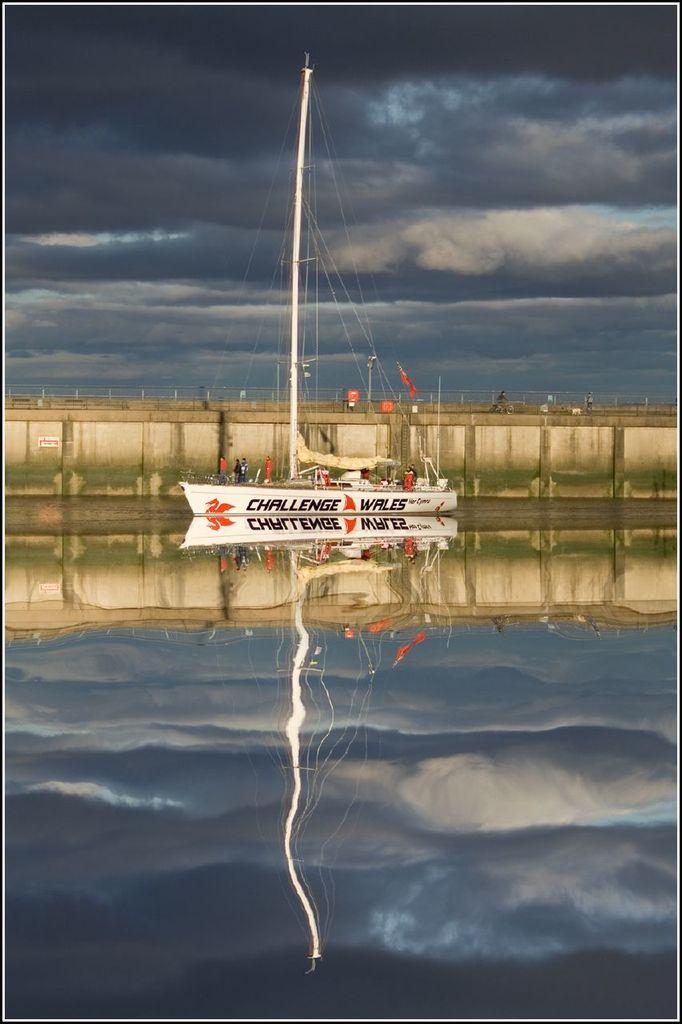What is in the water in the image? There is a boat in the water in the image. What can be seen in the background of the image? There is a wall in the background of the image. What is the weather like in the image? The presence of black clouds at the top of the image suggests that it might be overcast or stormy. What is inside the boat? There is a pole in the boat. What is connected to the pole? There are ropes attached to the pole. How many apples are on the boat in the image? There are no apples present in the image; the boat contains a pole with ropes attached. 